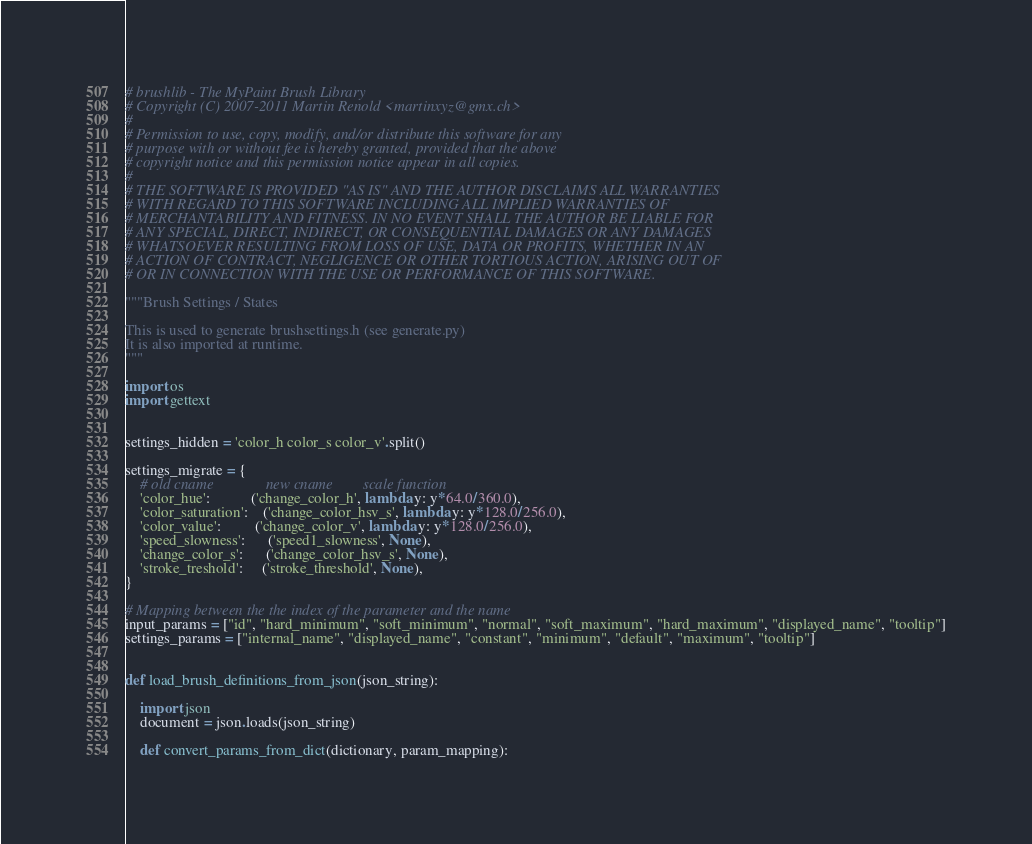Convert code to text. <code><loc_0><loc_0><loc_500><loc_500><_Python_># brushlib - The MyPaint Brush Library
# Copyright (C) 2007-2011 Martin Renold <martinxyz@gmx.ch>
#
# Permission to use, copy, modify, and/or distribute this software for any
# purpose with or without fee is hereby granted, provided that the above
# copyright notice and this permission notice appear in all copies.
#
# THE SOFTWARE IS PROVIDED "AS IS" AND THE AUTHOR DISCLAIMS ALL WARRANTIES
# WITH REGARD TO THIS SOFTWARE INCLUDING ALL IMPLIED WARRANTIES OF
# MERCHANTABILITY AND FITNESS. IN NO EVENT SHALL THE AUTHOR BE LIABLE FOR
# ANY SPECIAL, DIRECT, INDIRECT, OR CONSEQUENTIAL DAMAGES OR ANY DAMAGES
# WHATSOEVER RESULTING FROM LOSS OF USE, DATA OR PROFITS, WHETHER IN AN
# ACTION OF CONTRACT, NEGLIGENCE OR OTHER TORTIOUS ACTION, ARISING OUT OF
# OR IN CONNECTION WITH THE USE OR PERFORMANCE OF THIS SOFTWARE.

"""Brush Settings / States

This is used to generate brushsettings.h (see generate.py)
It is also imported at runtime.
"""

import os
import gettext


settings_hidden = 'color_h color_s color_v'.split()

settings_migrate = {
    # old cname              new cname        scale function
    'color_hue':           ('change_color_h', lambda y: y*64.0/360.0),
    'color_saturation':    ('change_color_hsv_s', lambda y: y*128.0/256.0),
    'color_value':         ('change_color_v', lambda y: y*128.0/256.0),
    'speed_slowness':      ('speed1_slowness', None),
    'change_color_s':      ('change_color_hsv_s', None),
    'stroke_treshold':     ('stroke_threshold', None),
}

# Mapping between the the index of the parameter and the name
input_params = ["id", "hard_minimum", "soft_minimum", "normal", "soft_maximum", "hard_maximum", "displayed_name", "tooltip"]
settings_params = ["internal_name", "displayed_name", "constant", "minimum", "default", "maximum", "tooltip"]


def load_brush_definitions_from_json(json_string):

    import json
    document = json.loads(json_string)

    def convert_params_from_dict(dictionary, param_mapping):</code> 